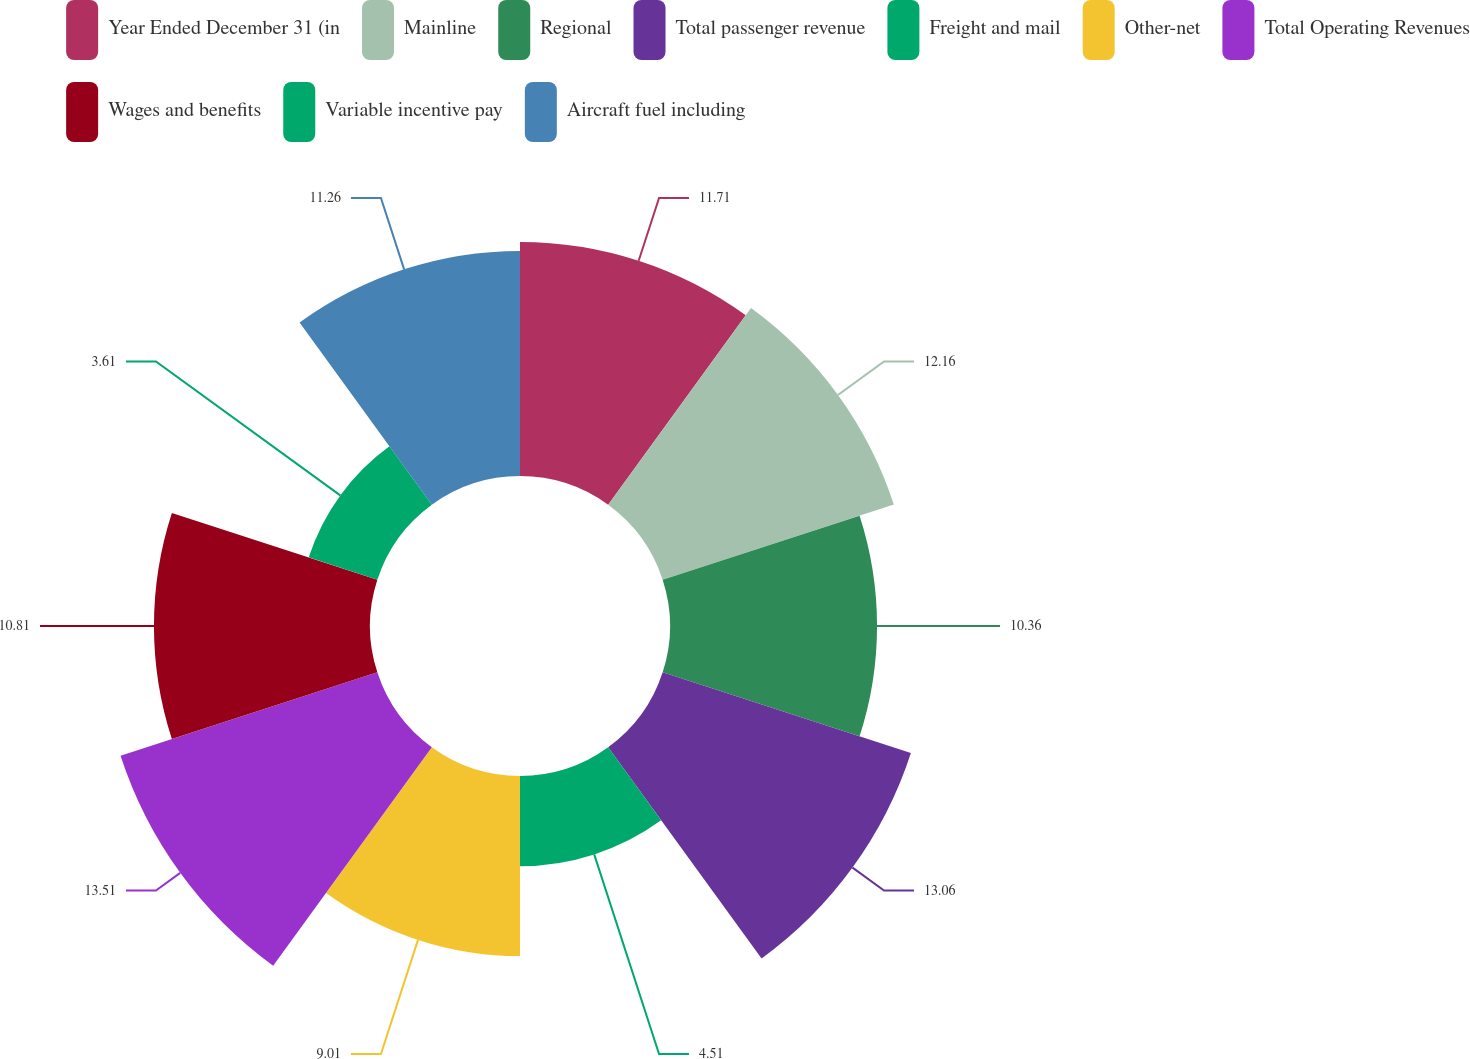Convert chart to OTSL. <chart><loc_0><loc_0><loc_500><loc_500><pie_chart><fcel>Year Ended December 31 (in<fcel>Mainline<fcel>Regional<fcel>Total passenger revenue<fcel>Freight and mail<fcel>Other-net<fcel>Total Operating Revenues<fcel>Wages and benefits<fcel>Variable incentive pay<fcel>Aircraft fuel including<nl><fcel>11.71%<fcel>12.16%<fcel>10.36%<fcel>13.06%<fcel>4.51%<fcel>9.01%<fcel>13.51%<fcel>10.81%<fcel>3.61%<fcel>11.26%<nl></chart> 